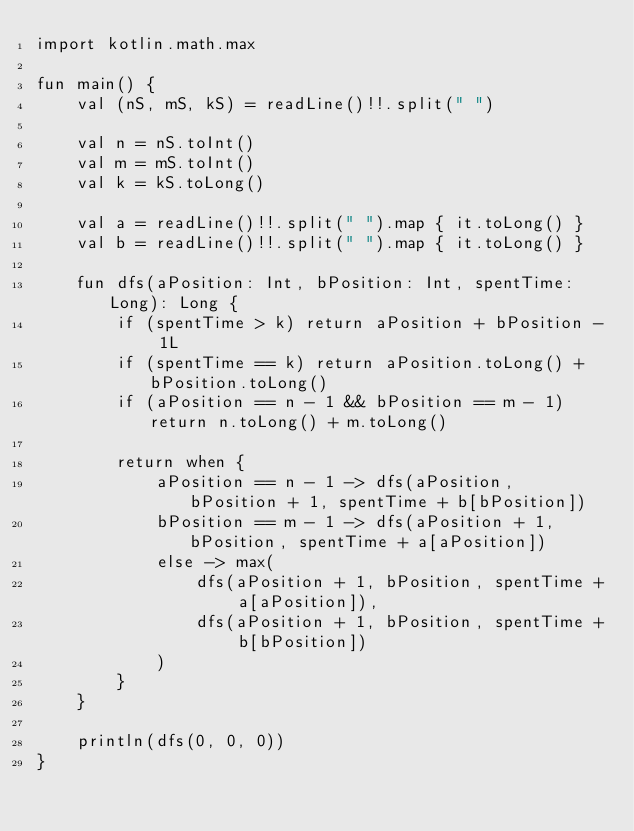<code> <loc_0><loc_0><loc_500><loc_500><_Kotlin_>import kotlin.math.max

fun main() {
    val (nS, mS, kS) = readLine()!!.split(" ")

    val n = nS.toInt()
    val m = mS.toInt()
    val k = kS.toLong()

    val a = readLine()!!.split(" ").map { it.toLong() }
    val b = readLine()!!.split(" ").map { it.toLong() }

    fun dfs(aPosition: Int, bPosition: Int, spentTime: Long): Long {
        if (spentTime > k) return aPosition + bPosition - 1L
        if (spentTime == k) return aPosition.toLong() + bPosition.toLong()
        if (aPosition == n - 1 && bPosition == m - 1) return n.toLong() + m.toLong()

        return when {
            aPosition == n - 1 -> dfs(aPosition, bPosition + 1, spentTime + b[bPosition])
            bPosition == m - 1 -> dfs(aPosition + 1, bPosition, spentTime + a[aPosition])
            else -> max(
                dfs(aPosition + 1, bPosition, spentTime + a[aPosition]),
                dfs(aPosition + 1, bPosition, spentTime + b[bPosition])
            )
        }
    }

    println(dfs(0, 0, 0))
}</code> 